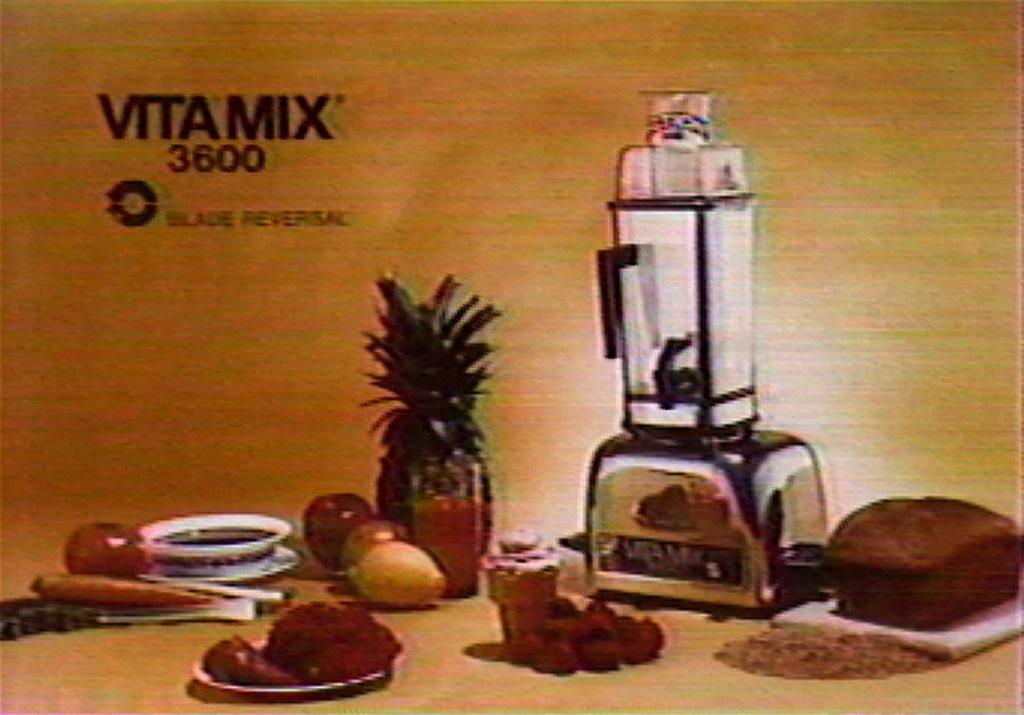<image>
Describe the image concisely. The Vitamix 3600 looks like an incredibly useful product. 